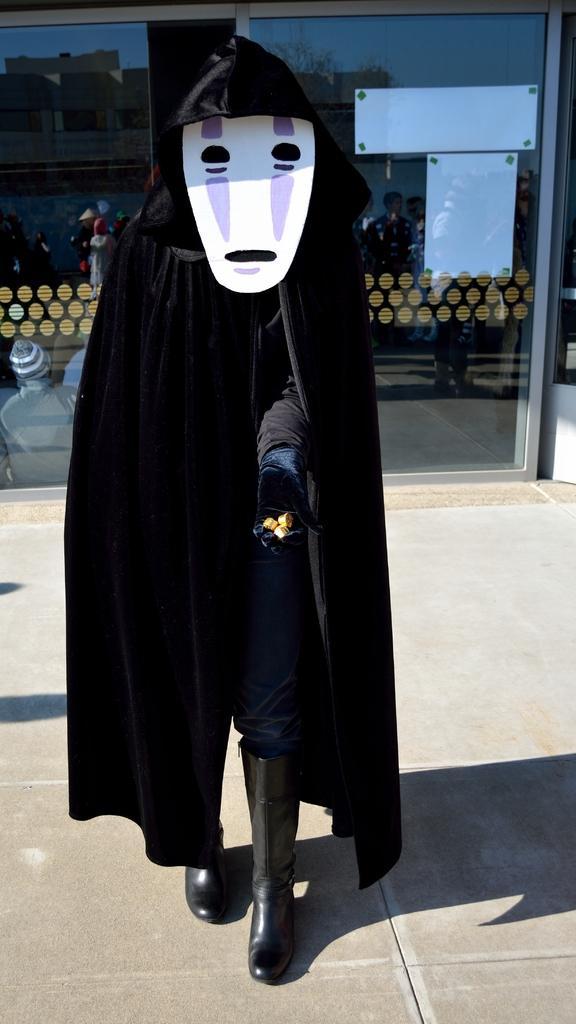Can you describe this image briefly? In this picture we can see a person wore a costume and standing on a surface and in the background we can see a glass and on this glass we can see some people, buildings and the sky. 